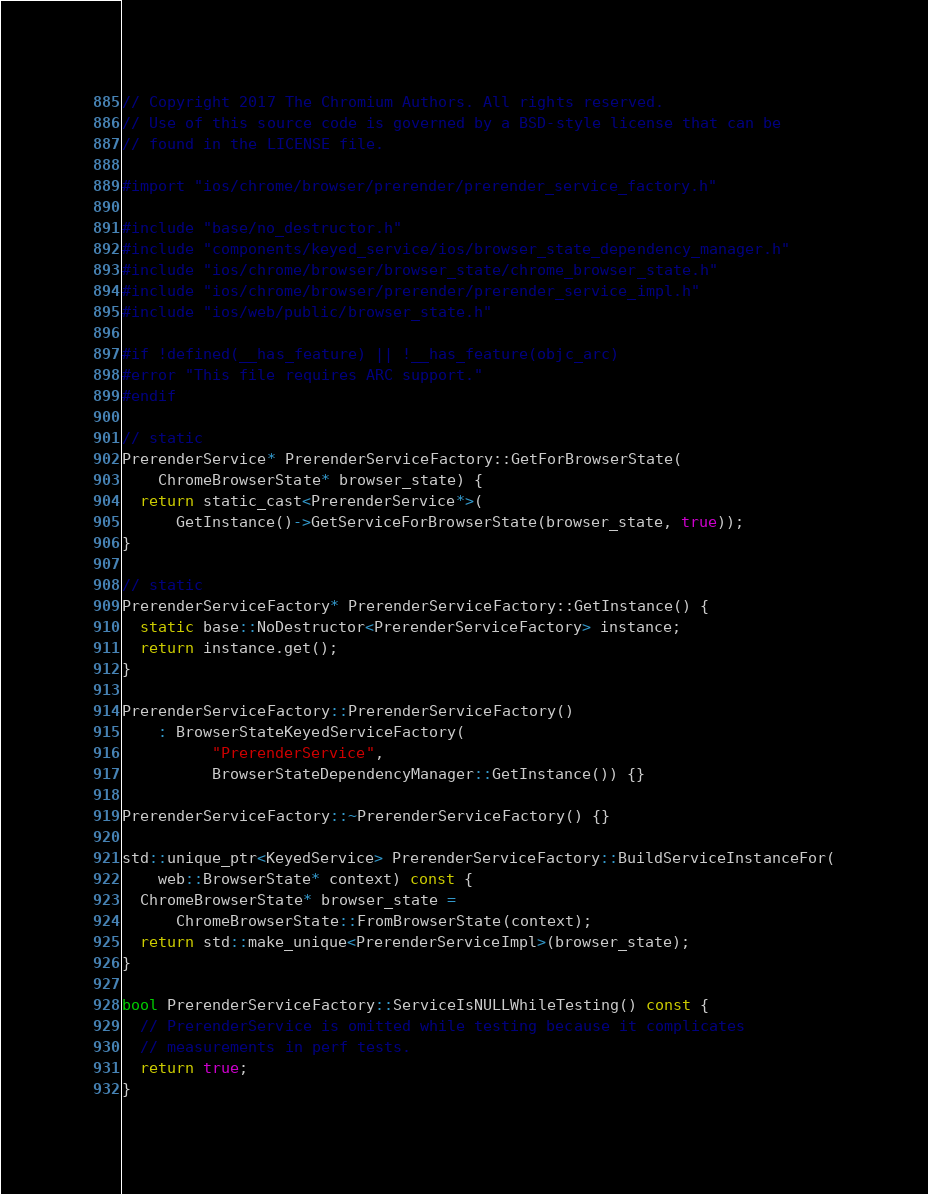Convert code to text. <code><loc_0><loc_0><loc_500><loc_500><_ObjectiveC_>// Copyright 2017 The Chromium Authors. All rights reserved.
// Use of this source code is governed by a BSD-style license that can be
// found in the LICENSE file.

#import "ios/chrome/browser/prerender/prerender_service_factory.h"

#include "base/no_destructor.h"
#include "components/keyed_service/ios/browser_state_dependency_manager.h"
#include "ios/chrome/browser/browser_state/chrome_browser_state.h"
#include "ios/chrome/browser/prerender/prerender_service_impl.h"
#include "ios/web/public/browser_state.h"

#if !defined(__has_feature) || !__has_feature(objc_arc)
#error "This file requires ARC support."
#endif

// static
PrerenderService* PrerenderServiceFactory::GetForBrowserState(
    ChromeBrowserState* browser_state) {
  return static_cast<PrerenderService*>(
      GetInstance()->GetServiceForBrowserState(browser_state, true));
}

// static
PrerenderServiceFactory* PrerenderServiceFactory::GetInstance() {
  static base::NoDestructor<PrerenderServiceFactory> instance;
  return instance.get();
}

PrerenderServiceFactory::PrerenderServiceFactory()
    : BrowserStateKeyedServiceFactory(
          "PrerenderService",
          BrowserStateDependencyManager::GetInstance()) {}

PrerenderServiceFactory::~PrerenderServiceFactory() {}

std::unique_ptr<KeyedService> PrerenderServiceFactory::BuildServiceInstanceFor(
    web::BrowserState* context) const {
  ChromeBrowserState* browser_state =
      ChromeBrowserState::FromBrowserState(context);
  return std::make_unique<PrerenderServiceImpl>(browser_state);
}

bool PrerenderServiceFactory::ServiceIsNULLWhileTesting() const {
  // PrerenderService is omitted while testing because it complicates
  // measurements in perf tests.
  return true;
}
</code> 